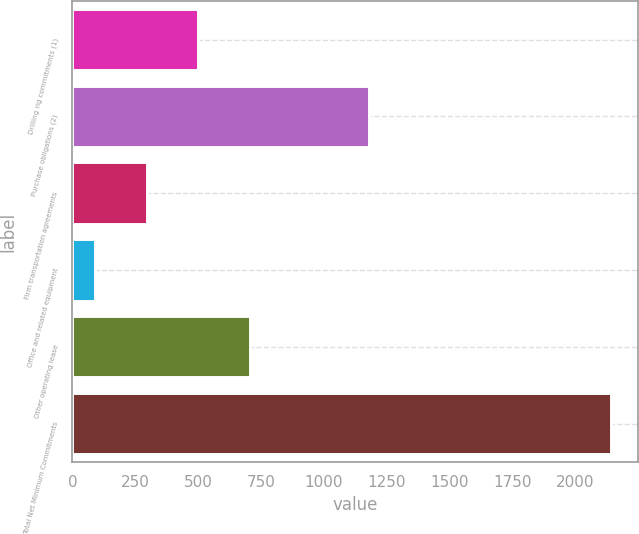<chart> <loc_0><loc_0><loc_500><loc_500><bar_chart><fcel>Drilling rig commitments (1)<fcel>Purchase obligations (2)<fcel>Firm transportation agreements<fcel>Office and related equipment<fcel>Other operating lease<fcel>Total Net Minimum Commitments<nl><fcel>501.2<fcel>1182<fcel>296.1<fcel>91<fcel>706.3<fcel>2142<nl></chart> 